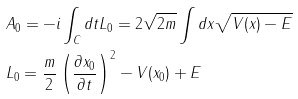<formula> <loc_0><loc_0><loc_500><loc_500>& A _ { 0 } = - i \int _ { C } d t L _ { 0 } = 2 \sqrt { 2 m } \int d x \sqrt { V ( x ) - E } \\ & L _ { 0 } = \frac { m } { 2 } \left ( \frac { \partial x _ { 0 } } { \partial t } \right ) ^ { 2 } - V ( x _ { 0 } ) + E</formula> 